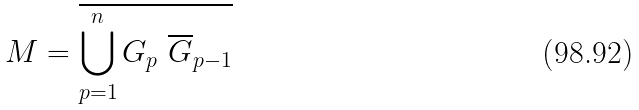Convert formula to latex. <formula><loc_0><loc_0><loc_500><loc_500>M = \overline { \overset { n } { \underset { p = 1 } { \bigcup } } \, G _ { p } \ \overline { G } _ { p - 1 } }</formula> 